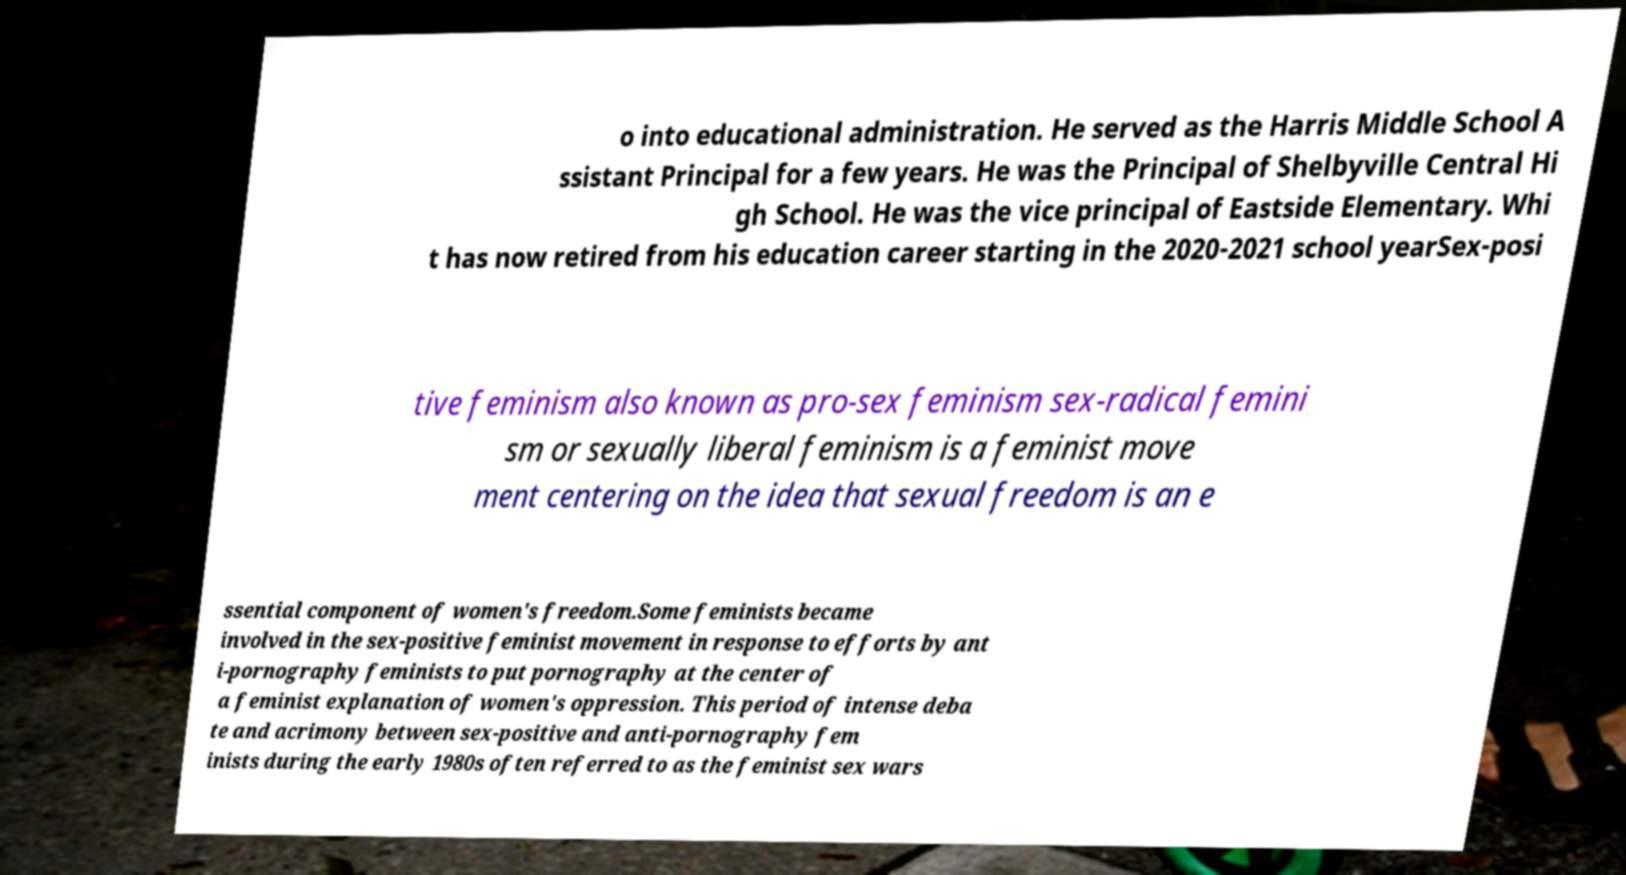Can you accurately transcribe the text from the provided image for me? o into educational administration. He served as the Harris Middle School A ssistant Principal for a few years. He was the Principal of Shelbyville Central Hi gh School. He was the vice principal of Eastside Elementary. Whi t has now retired from his education career starting in the 2020-2021 school yearSex-posi tive feminism also known as pro-sex feminism sex-radical femini sm or sexually liberal feminism is a feminist move ment centering on the idea that sexual freedom is an e ssential component of women's freedom.Some feminists became involved in the sex-positive feminist movement in response to efforts by ant i-pornography feminists to put pornography at the center of a feminist explanation of women's oppression. This period of intense deba te and acrimony between sex-positive and anti-pornography fem inists during the early 1980s often referred to as the feminist sex wars 